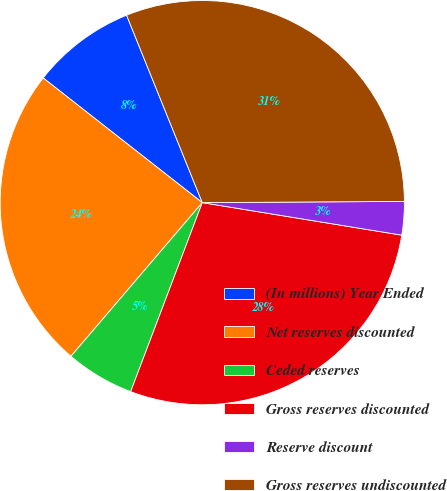Convert chart. <chart><loc_0><loc_0><loc_500><loc_500><pie_chart><fcel>(In millions) Year Ended<fcel>Net reserves discounted<fcel>Ceded reserves<fcel>Gross reserves discounted<fcel>Reserve discount<fcel>Gross reserves undiscounted<nl><fcel>8.31%<fcel>24.32%<fcel>5.49%<fcel>28.19%<fcel>2.67%<fcel>31.01%<nl></chart> 